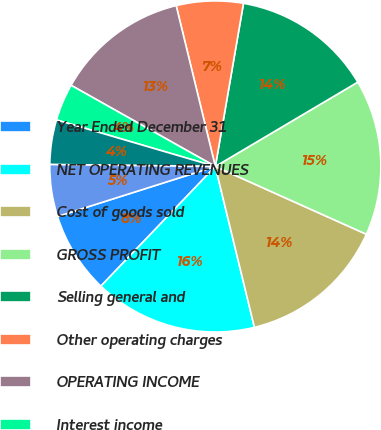Convert chart. <chart><loc_0><loc_0><loc_500><loc_500><pie_chart><fcel>Year Ended December 31<fcel>NET OPERATING REVENUES<fcel>Cost of goods sold<fcel>GROSS PROFIT<fcel>Selling general and<fcel>Other operating charges<fcel>OPERATING INCOME<fcel>Interest income<fcel>Interest expense<fcel>Equity income (loss) - net<nl><fcel>7.97%<fcel>15.94%<fcel>14.49%<fcel>15.22%<fcel>13.77%<fcel>6.52%<fcel>13.04%<fcel>3.62%<fcel>4.35%<fcel>5.07%<nl></chart> 